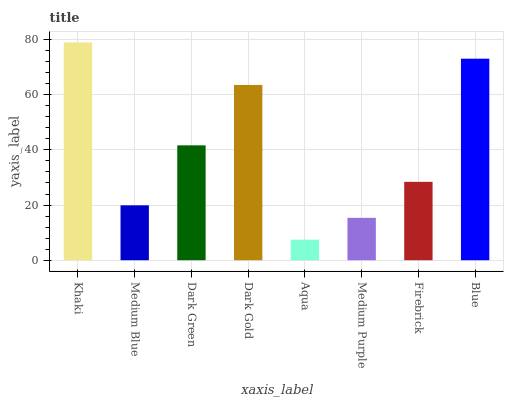Is Medium Blue the minimum?
Answer yes or no. No. Is Medium Blue the maximum?
Answer yes or no. No. Is Khaki greater than Medium Blue?
Answer yes or no. Yes. Is Medium Blue less than Khaki?
Answer yes or no. Yes. Is Medium Blue greater than Khaki?
Answer yes or no. No. Is Khaki less than Medium Blue?
Answer yes or no. No. Is Dark Green the high median?
Answer yes or no. Yes. Is Firebrick the low median?
Answer yes or no. Yes. Is Medium Blue the high median?
Answer yes or no. No. Is Dark Green the low median?
Answer yes or no. No. 